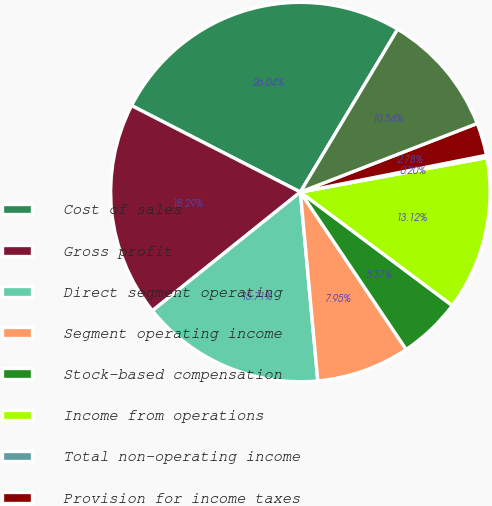Convert chart. <chart><loc_0><loc_0><loc_500><loc_500><pie_chart><fcel>Cost of sales<fcel>Gross profit<fcel>Direct segment operating<fcel>Segment operating income<fcel>Stock-based compensation<fcel>Income from operations<fcel>Total non-operating income<fcel>Provision for income taxes<fcel>Net income<nl><fcel>26.04%<fcel>18.29%<fcel>15.71%<fcel>7.95%<fcel>5.37%<fcel>13.12%<fcel>0.2%<fcel>2.78%<fcel>10.54%<nl></chart> 